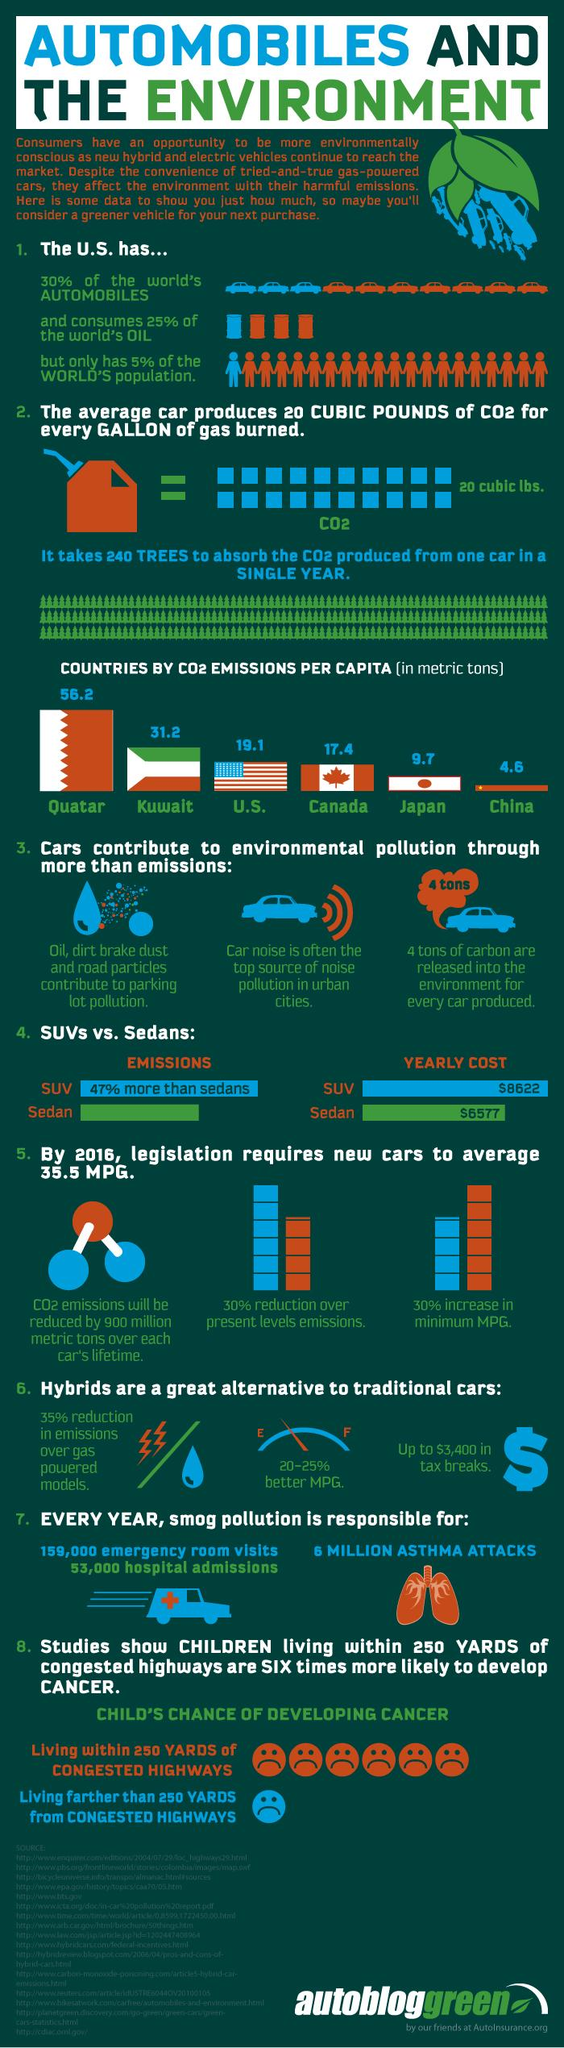Draw attention to some important aspects in this diagram. According to a recent estimate, over 95% of the world's population does not reside within the borders of the United States. The CO2 emissions per capita in Kuwait are 31.2 metric tons per year. According to a recent estimate, approximately 75% of the world's oil is not consumed by the United States. A significant percentage of the world's automobiles are not located in the United States. In Canada, the average per capita CO2 emissions are 17.4. 